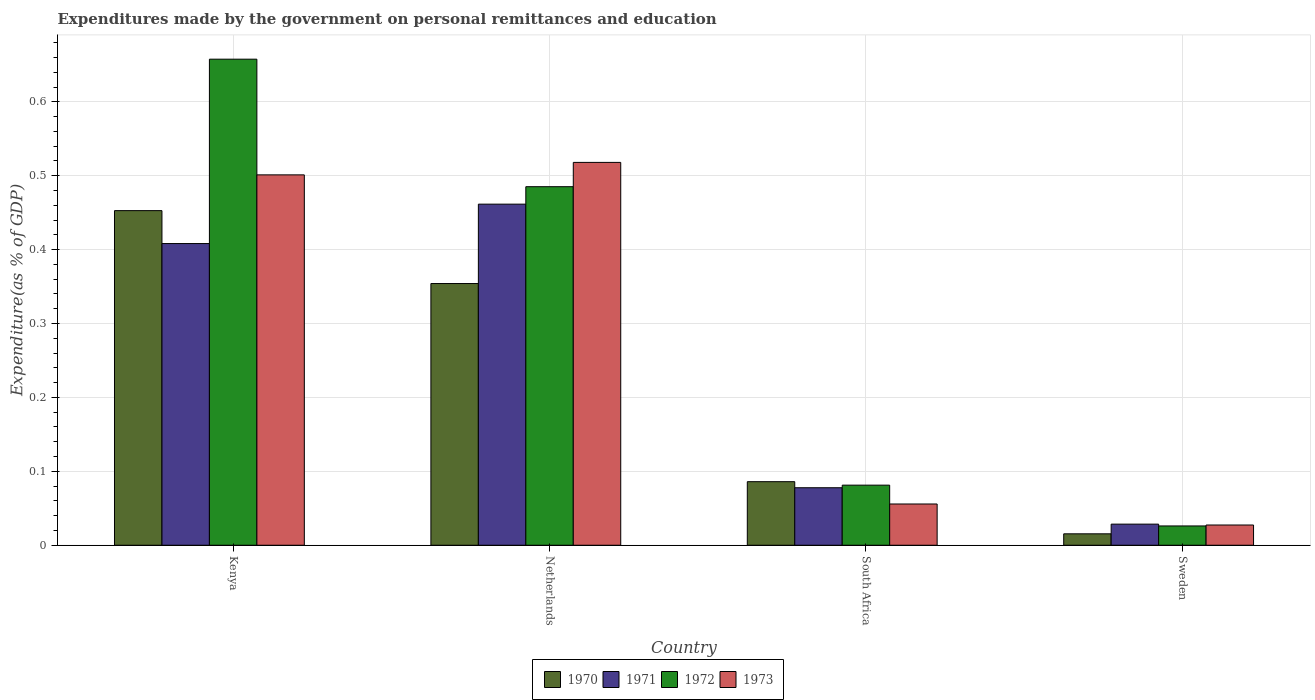How many different coloured bars are there?
Your answer should be very brief. 4. Are the number of bars on each tick of the X-axis equal?
Offer a terse response. Yes. How many bars are there on the 4th tick from the right?
Your answer should be compact. 4. What is the label of the 1st group of bars from the left?
Give a very brief answer. Kenya. What is the expenditures made by the government on personal remittances and education in 1972 in Netherlands?
Provide a short and direct response. 0.49. Across all countries, what is the maximum expenditures made by the government on personal remittances and education in 1973?
Your answer should be compact. 0.52. Across all countries, what is the minimum expenditures made by the government on personal remittances and education in 1973?
Give a very brief answer. 0.03. In which country was the expenditures made by the government on personal remittances and education in 1971 maximum?
Offer a very short reply. Netherlands. What is the total expenditures made by the government on personal remittances and education in 1972 in the graph?
Offer a very short reply. 1.25. What is the difference between the expenditures made by the government on personal remittances and education in 1970 in Netherlands and that in Sweden?
Offer a very short reply. 0.34. What is the difference between the expenditures made by the government on personal remittances and education in 1971 in Sweden and the expenditures made by the government on personal remittances and education in 1972 in South Africa?
Ensure brevity in your answer.  -0.05. What is the average expenditures made by the government on personal remittances and education in 1973 per country?
Your answer should be very brief. 0.28. What is the difference between the expenditures made by the government on personal remittances and education of/in 1970 and expenditures made by the government on personal remittances and education of/in 1972 in South Africa?
Provide a short and direct response. 0. What is the ratio of the expenditures made by the government on personal remittances and education in 1970 in South Africa to that in Sweden?
Provide a short and direct response. 5.57. What is the difference between the highest and the second highest expenditures made by the government on personal remittances and education in 1971?
Your answer should be compact. 0.05. What is the difference between the highest and the lowest expenditures made by the government on personal remittances and education in 1973?
Keep it short and to the point. 0.49. In how many countries, is the expenditures made by the government on personal remittances and education in 1971 greater than the average expenditures made by the government on personal remittances and education in 1971 taken over all countries?
Provide a short and direct response. 2. Is the sum of the expenditures made by the government on personal remittances and education in 1972 in South Africa and Sweden greater than the maximum expenditures made by the government on personal remittances and education in 1971 across all countries?
Offer a very short reply. No. Is it the case that in every country, the sum of the expenditures made by the government on personal remittances and education in 1973 and expenditures made by the government on personal remittances and education in 1972 is greater than the sum of expenditures made by the government on personal remittances and education in 1970 and expenditures made by the government on personal remittances and education in 1971?
Your answer should be compact. No. What does the 3rd bar from the left in Kenya represents?
Ensure brevity in your answer.  1972. Are all the bars in the graph horizontal?
Keep it short and to the point. No. Are the values on the major ticks of Y-axis written in scientific E-notation?
Provide a short and direct response. No. Does the graph contain any zero values?
Provide a short and direct response. No. Does the graph contain grids?
Your response must be concise. Yes. How many legend labels are there?
Your answer should be very brief. 4. How are the legend labels stacked?
Offer a terse response. Horizontal. What is the title of the graph?
Offer a terse response. Expenditures made by the government on personal remittances and education. What is the label or title of the X-axis?
Your response must be concise. Country. What is the label or title of the Y-axis?
Your response must be concise. Expenditure(as % of GDP). What is the Expenditure(as % of GDP) in 1970 in Kenya?
Provide a succinct answer. 0.45. What is the Expenditure(as % of GDP) of 1971 in Kenya?
Your answer should be very brief. 0.41. What is the Expenditure(as % of GDP) in 1972 in Kenya?
Keep it short and to the point. 0.66. What is the Expenditure(as % of GDP) in 1973 in Kenya?
Give a very brief answer. 0.5. What is the Expenditure(as % of GDP) in 1970 in Netherlands?
Make the answer very short. 0.35. What is the Expenditure(as % of GDP) of 1971 in Netherlands?
Offer a very short reply. 0.46. What is the Expenditure(as % of GDP) of 1972 in Netherlands?
Offer a terse response. 0.49. What is the Expenditure(as % of GDP) in 1973 in Netherlands?
Make the answer very short. 0.52. What is the Expenditure(as % of GDP) in 1970 in South Africa?
Make the answer very short. 0.09. What is the Expenditure(as % of GDP) of 1971 in South Africa?
Your response must be concise. 0.08. What is the Expenditure(as % of GDP) of 1972 in South Africa?
Make the answer very short. 0.08. What is the Expenditure(as % of GDP) of 1973 in South Africa?
Your answer should be very brief. 0.06. What is the Expenditure(as % of GDP) in 1970 in Sweden?
Your answer should be very brief. 0.02. What is the Expenditure(as % of GDP) of 1971 in Sweden?
Provide a succinct answer. 0.03. What is the Expenditure(as % of GDP) of 1972 in Sweden?
Offer a terse response. 0.03. What is the Expenditure(as % of GDP) of 1973 in Sweden?
Your answer should be very brief. 0.03. Across all countries, what is the maximum Expenditure(as % of GDP) in 1970?
Your answer should be very brief. 0.45. Across all countries, what is the maximum Expenditure(as % of GDP) in 1971?
Your answer should be very brief. 0.46. Across all countries, what is the maximum Expenditure(as % of GDP) of 1972?
Ensure brevity in your answer.  0.66. Across all countries, what is the maximum Expenditure(as % of GDP) of 1973?
Provide a short and direct response. 0.52. Across all countries, what is the minimum Expenditure(as % of GDP) of 1970?
Provide a succinct answer. 0.02. Across all countries, what is the minimum Expenditure(as % of GDP) in 1971?
Ensure brevity in your answer.  0.03. Across all countries, what is the minimum Expenditure(as % of GDP) in 1972?
Give a very brief answer. 0.03. Across all countries, what is the minimum Expenditure(as % of GDP) in 1973?
Your answer should be very brief. 0.03. What is the total Expenditure(as % of GDP) of 1970 in the graph?
Provide a short and direct response. 0.91. What is the total Expenditure(as % of GDP) of 1971 in the graph?
Provide a succinct answer. 0.98. What is the total Expenditure(as % of GDP) of 1972 in the graph?
Make the answer very short. 1.25. What is the total Expenditure(as % of GDP) of 1973 in the graph?
Your answer should be compact. 1.1. What is the difference between the Expenditure(as % of GDP) of 1970 in Kenya and that in Netherlands?
Offer a very short reply. 0.1. What is the difference between the Expenditure(as % of GDP) in 1971 in Kenya and that in Netherlands?
Offer a terse response. -0.05. What is the difference between the Expenditure(as % of GDP) of 1972 in Kenya and that in Netherlands?
Offer a terse response. 0.17. What is the difference between the Expenditure(as % of GDP) of 1973 in Kenya and that in Netherlands?
Provide a succinct answer. -0.02. What is the difference between the Expenditure(as % of GDP) of 1970 in Kenya and that in South Africa?
Keep it short and to the point. 0.37. What is the difference between the Expenditure(as % of GDP) in 1971 in Kenya and that in South Africa?
Provide a short and direct response. 0.33. What is the difference between the Expenditure(as % of GDP) of 1972 in Kenya and that in South Africa?
Provide a succinct answer. 0.58. What is the difference between the Expenditure(as % of GDP) of 1973 in Kenya and that in South Africa?
Your answer should be very brief. 0.45. What is the difference between the Expenditure(as % of GDP) in 1970 in Kenya and that in Sweden?
Offer a very short reply. 0.44. What is the difference between the Expenditure(as % of GDP) in 1971 in Kenya and that in Sweden?
Offer a terse response. 0.38. What is the difference between the Expenditure(as % of GDP) of 1972 in Kenya and that in Sweden?
Offer a very short reply. 0.63. What is the difference between the Expenditure(as % of GDP) of 1973 in Kenya and that in Sweden?
Give a very brief answer. 0.47. What is the difference between the Expenditure(as % of GDP) of 1970 in Netherlands and that in South Africa?
Make the answer very short. 0.27. What is the difference between the Expenditure(as % of GDP) of 1971 in Netherlands and that in South Africa?
Your response must be concise. 0.38. What is the difference between the Expenditure(as % of GDP) in 1972 in Netherlands and that in South Africa?
Your answer should be compact. 0.4. What is the difference between the Expenditure(as % of GDP) in 1973 in Netherlands and that in South Africa?
Offer a very short reply. 0.46. What is the difference between the Expenditure(as % of GDP) in 1970 in Netherlands and that in Sweden?
Give a very brief answer. 0.34. What is the difference between the Expenditure(as % of GDP) in 1971 in Netherlands and that in Sweden?
Your answer should be compact. 0.43. What is the difference between the Expenditure(as % of GDP) in 1972 in Netherlands and that in Sweden?
Offer a very short reply. 0.46. What is the difference between the Expenditure(as % of GDP) in 1973 in Netherlands and that in Sweden?
Provide a short and direct response. 0.49. What is the difference between the Expenditure(as % of GDP) of 1970 in South Africa and that in Sweden?
Provide a short and direct response. 0.07. What is the difference between the Expenditure(as % of GDP) of 1971 in South Africa and that in Sweden?
Your answer should be very brief. 0.05. What is the difference between the Expenditure(as % of GDP) of 1972 in South Africa and that in Sweden?
Give a very brief answer. 0.06. What is the difference between the Expenditure(as % of GDP) in 1973 in South Africa and that in Sweden?
Ensure brevity in your answer.  0.03. What is the difference between the Expenditure(as % of GDP) in 1970 in Kenya and the Expenditure(as % of GDP) in 1971 in Netherlands?
Ensure brevity in your answer.  -0.01. What is the difference between the Expenditure(as % of GDP) of 1970 in Kenya and the Expenditure(as % of GDP) of 1972 in Netherlands?
Ensure brevity in your answer.  -0.03. What is the difference between the Expenditure(as % of GDP) of 1970 in Kenya and the Expenditure(as % of GDP) of 1973 in Netherlands?
Your answer should be compact. -0.07. What is the difference between the Expenditure(as % of GDP) in 1971 in Kenya and the Expenditure(as % of GDP) in 1972 in Netherlands?
Make the answer very short. -0.08. What is the difference between the Expenditure(as % of GDP) of 1971 in Kenya and the Expenditure(as % of GDP) of 1973 in Netherlands?
Your response must be concise. -0.11. What is the difference between the Expenditure(as % of GDP) of 1972 in Kenya and the Expenditure(as % of GDP) of 1973 in Netherlands?
Provide a succinct answer. 0.14. What is the difference between the Expenditure(as % of GDP) in 1970 in Kenya and the Expenditure(as % of GDP) in 1971 in South Africa?
Your answer should be very brief. 0.38. What is the difference between the Expenditure(as % of GDP) of 1970 in Kenya and the Expenditure(as % of GDP) of 1972 in South Africa?
Your answer should be compact. 0.37. What is the difference between the Expenditure(as % of GDP) of 1970 in Kenya and the Expenditure(as % of GDP) of 1973 in South Africa?
Your answer should be compact. 0.4. What is the difference between the Expenditure(as % of GDP) of 1971 in Kenya and the Expenditure(as % of GDP) of 1972 in South Africa?
Ensure brevity in your answer.  0.33. What is the difference between the Expenditure(as % of GDP) of 1971 in Kenya and the Expenditure(as % of GDP) of 1973 in South Africa?
Keep it short and to the point. 0.35. What is the difference between the Expenditure(as % of GDP) of 1972 in Kenya and the Expenditure(as % of GDP) of 1973 in South Africa?
Offer a terse response. 0.6. What is the difference between the Expenditure(as % of GDP) in 1970 in Kenya and the Expenditure(as % of GDP) in 1971 in Sweden?
Your response must be concise. 0.42. What is the difference between the Expenditure(as % of GDP) in 1970 in Kenya and the Expenditure(as % of GDP) in 1972 in Sweden?
Offer a very short reply. 0.43. What is the difference between the Expenditure(as % of GDP) of 1970 in Kenya and the Expenditure(as % of GDP) of 1973 in Sweden?
Provide a succinct answer. 0.43. What is the difference between the Expenditure(as % of GDP) in 1971 in Kenya and the Expenditure(as % of GDP) in 1972 in Sweden?
Your response must be concise. 0.38. What is the difference between the Expenditure(as % of GDP) in 1971 in Kenya and the Expenditure(as % of GDP) in 1973 in Sweden?
Offer a very short reply. 0.38. What is the difference between the Expenditure(as % of GDP) of 1972 in Kenya and the Expenditure(as % of GDP) of 1973 in Sweden?
Your answer should be very brief. 0.63. What is the difference between the Expenditure(as % of GDP) in 1970 in Netherlands and the Expenditure(as % of GDP) in 1971 in South Africa?
Your response must be concise. 0.28. What is the difference between the Expenditure(as % of GDP) of 1970 in Netherlands and the Expenditure(as % of GDP) of 1972 in South Africa?
Your answer should be very brief. 0.27. What is the difference between the Expenditure(as % of GDP) in 1970 in Netherlands and the Expenditure(as % of GDP) in 1973 in South Africa?
Provide a succinct answer. 0.3. What is the difference between the Expenditure(as % of GDP) in 1971 in Netherlands and the Expenditure(as % of GDP) in 1972 in South Africa?
Your response must be concise. 0.38. What is the difference between the Expenditure(as % of GDP) of 1971 in Netherlands and the Expenditure(as % of GDP) of 1973 in South Africa?
Your answer should be compact. 0.41. What is the difference between the Expenditure(as % of GDP) in 1972 in Netherlands and the Expenditure(as % of GDP) in 1973 in South Africa?
Keep it short and to the point. 0.43. What is the difference between the Expenditure(as % of GDP) in 1970 in Netherlands and the Expenditure(as % of GDP) in 1971 in Sweden?
Your answer should be compact. 0.33. What is the difference between the Expenditure(as % of GDP) in 1970 in Netherlands and the Expenditure(as % of GDP) in 1972 in Sweden?
Your response must be concise. 0.33. What is the difference between the Expenditure(as % of GDP) of 1970 in Netherlands and the Expenditure(as % of GDP) of 1973 in Sweden?
Offer a terse response. 0.33. What is the difference between the Expenditure(as % of GDP) in 1971 in Netherlands and the Expenditure(as % of GDP) in 1972 in Sweden?
Provide a succinct answer. 0.44. What is the difference between the Expenditure(as % of GDP) of 1971 in Netherlands and the Expenditure(as % of GDP) of 1973 in Sweden?
Your answer should be compact. 0.43. What is the difference between the Expenditure(as % of GDP) in 1972 in Netherlands and the Expenditure(as % of GDP) in 1973 in Sweden?
Your answer should be compact. 0.46. What is the difference between the Expenditure(as % of GDP) of 1970 in South Africa and the Expenditure(as % of GDP) of 1971 in Sweden?
Provide a succinct answer. 0.06. What is the difference between the Expenditure(as % of GDP) in 1970 in South Africa and the Expenditure(as % of GDP) in 1972 in Sweden?
Offer a very short reply. 0.06. What is the difference between the Expenditure(as % of GDP) of 1970 in South Africa and the Expenditure(as % of GDP) of 1973 in Sweden?
Your response must be concise. 0.06. What is the difference between the Expenditure(as % of GDP) of 1971 in South Africa and the Expenditure(as % of GDP) of 1972 in Sweden?
Make the answer very short. 0.05. What is the difference between the Expenditure(as % of GDP) of 1971 in South Africa and the Expenditure(as % of GDP) of 1973 in Sweden?
Offer a terse response. 0.05. What is the difference between the Expenditure(as % of GDP) of 1972 in South Africa and the Expenditure(as % of GDP) of 1973 in Sweden?
Provide a succinct answer. 0.05. What is the average Expenditure(as % of GDP) in 1970 per country?
Your answer should be very brief. 0.23. What is the average Expenditure(as % of GDP) in 1971 per country?
Provide a succinct answer. 0.24. What is the average Expenditure(as % of GDP) in 1972 per country?
Ensure brevity in your answer.  0.31. What is the average Expenditure(as % of GDP) of 1973 per country?
Offer a very short reply. 0.28. What is the difference between the Expenditure(as % of GDP) in 1970 and Expenditure(as % of GDP) in 1971 in Kenya?
Your answer should be very brief. 0.04. What is the difference between the Expenditure(as % of GDP) of 1970 and Expenditure(as % of GDP) of 1972 in Kenya?
Offer a terse response. -0.2. What is the difference between the Expenditure(as % of GDP) in 1970 and Expenditure(as % of GDP) in 1973 in Kenya?
Provide a short and direct response. -0.05. What is the difference between the Expenditure(as % of GDP) in 1971 and Expenditure(as % of GDP) in 1972 in Kenya?
Provide a short and direct response. -0.25. What is the difference between the Expenditure(as % of GDP) in 1971 and Expenditure(as % of GDP) in 1973 in Kenya?
Offer a terse response. -0.09. What is the difference between the Expenditure(as % of GDP) in 1972 and Expenditure(as % of GDP) in 1973 in Kenya?
Offer a very short reply. 0.16. What is the difference between the Expenditure(as % of GDP) of 1970 and Expenditure(as % of GDP) of 1971 in Netherlands?
Ensure brevity in your answer.  -0.11. What is the difference between the Expenditure(as % of GDP) in 1970 and Expenditure(as % of GDP) in 1972 in Netherlands?
Offer a terse response. -0.13. What is the difference between the Expenditure(as % of GDP) in 1970 and Expenditure(as % of GDP) in 1973 in Netherlands?
Your response must be concise. -0.16. What is the difference between the Expenditure(as % of GDP) in 1971 and Expenditure(as % of GDP) in 1972 in Netherlands?
Provide a succinct answer. -0.02. What is the difference between the Expenditure(as % of GDP) in 1971 and Expenditure(as % of GDP) in 1973 in Netherlands?
Give a very brief answer. -0.06. What is the difference between the Expenditure(as % of GDP) of 1972 and Expenditure(as % of GDP) of 1973 in Netherlands?
Offer a very short reply. -0.03. What is the difference between the Expenditure(as % of GDP) of 1970 and Expenditure(as % of GDP) of 1971 in South Africa?
Provide a short and direct response. 0.01. What is the difference between the Expenditure(as % of GDP) of 1970 and Expenditure(as % of GDP) of 1972 in South Africa?
Your answer should be very brief. 0. What is the difference between the Expenditure(as % of GDP) of 1970 and Expenditure(as % of GDP) of 1973 in South Africa?
Offer a terse response. 0.03. What is the difference between the Expenditure(as % of GDP) in 1971 and Expenditure(as % of GDP) in 1972 in South Africa?
Ensure brevity in your answer.  -0. What is the difference between the Expenditure(as % of GDP) in 1971 and Expenditure(as % of GDP) in 1973 in South Africa?
Provide a short and direct response. 0.02. What is the difference between the Expenditure(as % of GDP) in 1972 and Expenditure(as % of GDP) in 1973 in South Africa?
Your answer should be very brief. 0.03. What is the difference between the Expenditure(as % of GDP) in 1970 and Expenditure(as % of GDP) in 1971 in Sweden?
Give a very brief answer. -0.01. What is the difference between the Expenditure(as % of GDP) of 1970 and Expenditure(as % of GDP) of 1972 in Sweden?
Ensure brevity in your answer.  -0.01. What is the difference between the Expenditure(as % of GDP) of 1970 and Expenditure(as % of GDP) of 1973 in Sweden?
Offer a very short reply. -0.01. What is the difference between the Expenditure(as % of GDP) of 1971 and Expenditure(as % of GDP) of 1972 in Sweden?
Offer a terse response. 0. What is the difference between the Expenditure(as % of GDP) of 1971 and Expenditure(as % of GDP) of 1973 in Sweden?
Your answer should be very brief. 0. What is the difference between the Expenditure(as % of GDP) of 1972 and Expenditure(as % of GDP) of 1973 in Sweden?
Your answer should be compact. -0. What is the ratio of the Expenditure(as % of GDP) in 1970 in Kenya to that in Netherlands?
Provide a short and direct response. 1.28. What is the ratio of the Expenditure(as % of GDP) of 1971 in Kenya to that in Netherlands?
Your answer should be compact. 0.88. What is the ratio of the Expenditure(as % of GDP) of 1972 in Kenya to that in Netherlands?
Give a very brief answer. 1.36. What is the ratio of the Expenditure(as % of GDP) in 1973 in Kenya to that in Netherlands?
Give a very brief answer. 0.97. What is the ratio of the Expenditure(as % of GDP) in 1970 in Kenya to that in South Africa?
Your answer should be compact. 5.26. What is the ratio of the Expenditure(as % of GDP) in 1971 in Kenya to that in South Africa?
Provide a short and direct response. 5.25. What is the ratio of the Expenditure(as % of GDP) in 1972 in Kenya to that in South Africa?
Your answer should be compact. 8.09. What is the ratio of the Expenditure(as % of GDP) in 1973 in Kenya to that in South Africa?
Ensure brevity in your answer.  8.98. What is the ratio of the Expenditure(as % of GDP) of 1970 in Kenya to that in Sweden?
Your response must be concise. 29.32. What is the ratio of the Expenditure(as % of GDP) in 1971 in Kenya to that in Sweden?
Make the answer very short. 14.29. What is the ratio of the Expenditure(as % of GDP) in 1972 in Kenya to that in Sweden?
Make the answer very short. 25.2. What is the ratio of the Expenditure(as % of GDP) of 1973 in Kenya to that in Sweden?
Keep it short and to the point. 18.31. What is the ratio of the Expenditure(as % of GDP) of 1970 in Netherlands to that in South Africa?
Keep it short and to the point. 4.12. What is the ratio of the Expenditure(as % of GDP) of 1971 in Netherlands to that in South Africa?
Give a very brief answer. 5.93. What is the ratio of the Expenditure(as % of GDP) of 1972 in Netherlands to that in South Africa?
Keep it short and to the point. 5.97. What is the ratio of the Expenditure(as % of GDP) of 1973 in Netherlands to that in South Africa?
Give a very brief answer. 9.28. What is the ratio of the Expenditure(as % of GDP) in 1970 in Netherlands to that in Sweden?
Offer a terse response. 22.93. What is the ratio of the Expenditure(as % of GDP) in 1971 in Netherlands to that in Sweden?
Give a very brief answer. 16.16. What is the ratio of the Expenditure(as % of GDP) of 1972 in Netherlands to that in Sweden?
Offer a terse response. 18.59. What is the ratio of the Expenditure(as % of GDP) of 1973 in Netherlands to that in Sweden?
Your answer should be very brief. 18.93. What is the ratio of the Expenditure(as % of GDP) in 1970 in South Africa to that in Sweden?
Offer a terse response. 5.57. What is the ratio of the Expenditure(as % of GDP) in 1971 in South Africa to that in Sweden?
Offer a terse response. 2.72. What is the ratio of the Expenditure(as % of GDP) of 1972 in South Africa to that in Sweden?
Give a very brief answer. 3.11. What is the ratio of the Expenditure(as % of GDP) of 1973 in South Africa to that in Sweden?
Keep it short and to the point. 2.04. What is the difference between the highest and the second highest Expenditure(as % of GDP) in 1970?
Your response must be concise. 0.1. What is the difference between the highest and the second highest Expenditure(as % of GDP) of 1971?
Make the answer very short. 0.05. What is the difference between the highest and the second highest Expenditure(as % of GDP) in 1972?
Provide a succinct answer. 0.17. What is the difference between the highest and the second highest Expenditure(as % of GDP) of 1973?
Your answer should be very brief. 0.02. What is the difference between the highest and the lowest Expenditure(as % of GDP) of 1970?
Offer a very short reply. 0.44. What is the difference between the highest and the lowest Expenditure(as % of GDP) of 1971?
Your answer should be very brief. 0.43. What is the difference between the highest and the lowest Expenditure(as % of GDP) of 1972?
Make the answer very short. 0.63. What is the difference between the highest and the lowest Expenditure(as % of GDP) in 1973?
Your answer should be compact. 0.49. 